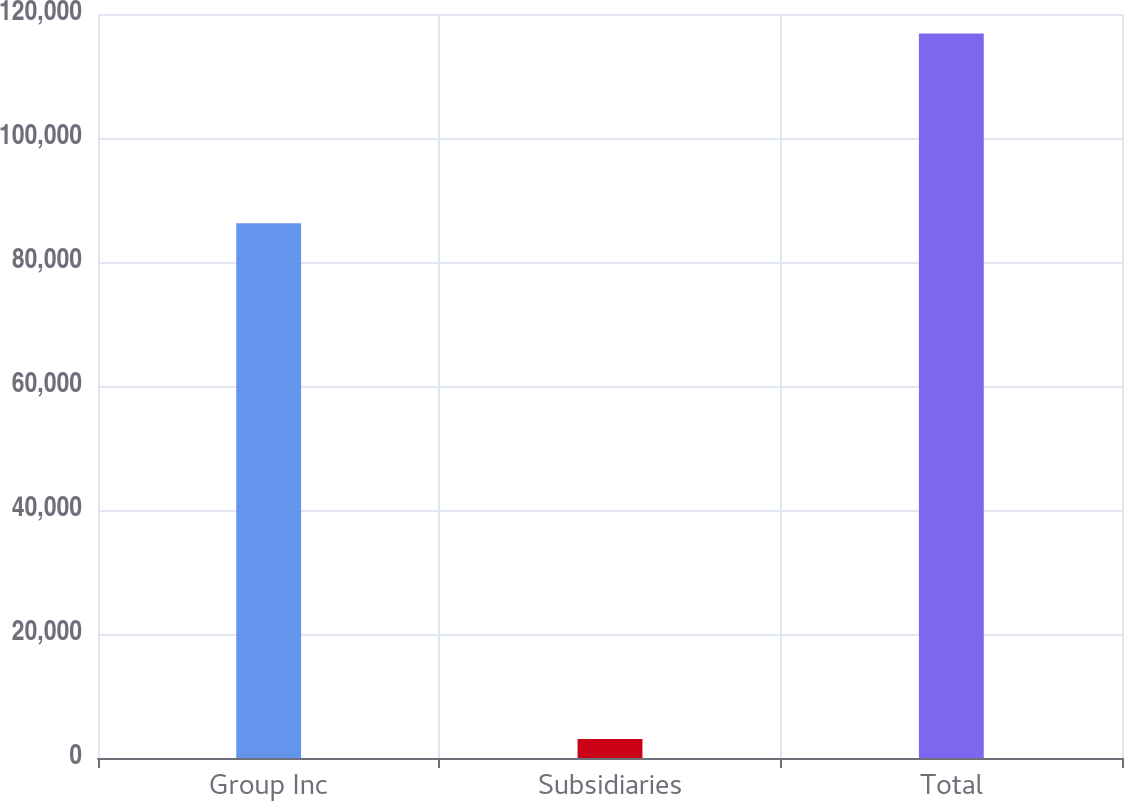<chart> <loc_0><loc_0><loc_500><loc_500><bar_chart><fcel>Group Inc<fcel>Subsidiaries<fcel>Total<nl><fcel>86255<fcel>3062<fcel>116850<nl></chart> 